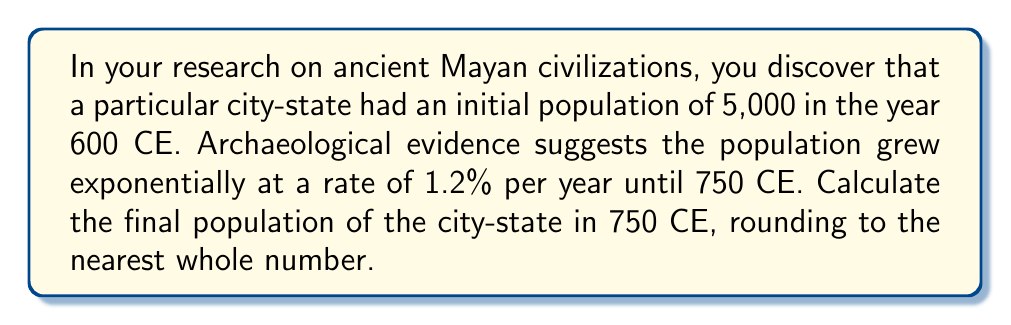What is the answer to this math problem? To solve this problem, we'll use the exponential growth formula:

$$A = P(1 + r)^t$$

Where:
$A$ = Final amount
$P$ = Initial principal (starting population)
$r$ = Growth rate (as a decimal)
$t$ = Time period

Given:
$P = 5,000$ (initial population)
$r = 0.012$ (1.2% expressed as a decimal)
$t = 150$ years (from 600 CE to 750 CE)

Let's substitute these values into the formula:

$$A = 5,000(1 + 0.012)^{150}$$

Now, let's calculate step-by-step:

1) First, calculate $(1 + 0.012)$:
   $1 + 0.012 = 1.012$

2) Now, we need to calculate $1.012^{150}$:
   $1.012^{150} \approx 5.8743$ (using a calculator)

3) Multiply this by the initial population:
   $5,000 \times 5.8743 \approx 29,371.5$

4) Round to the nearest whole number:
   $29,372$

Therefore, the final population in 750 CE would be approximately 29,372 people.
Answer: 29,372 